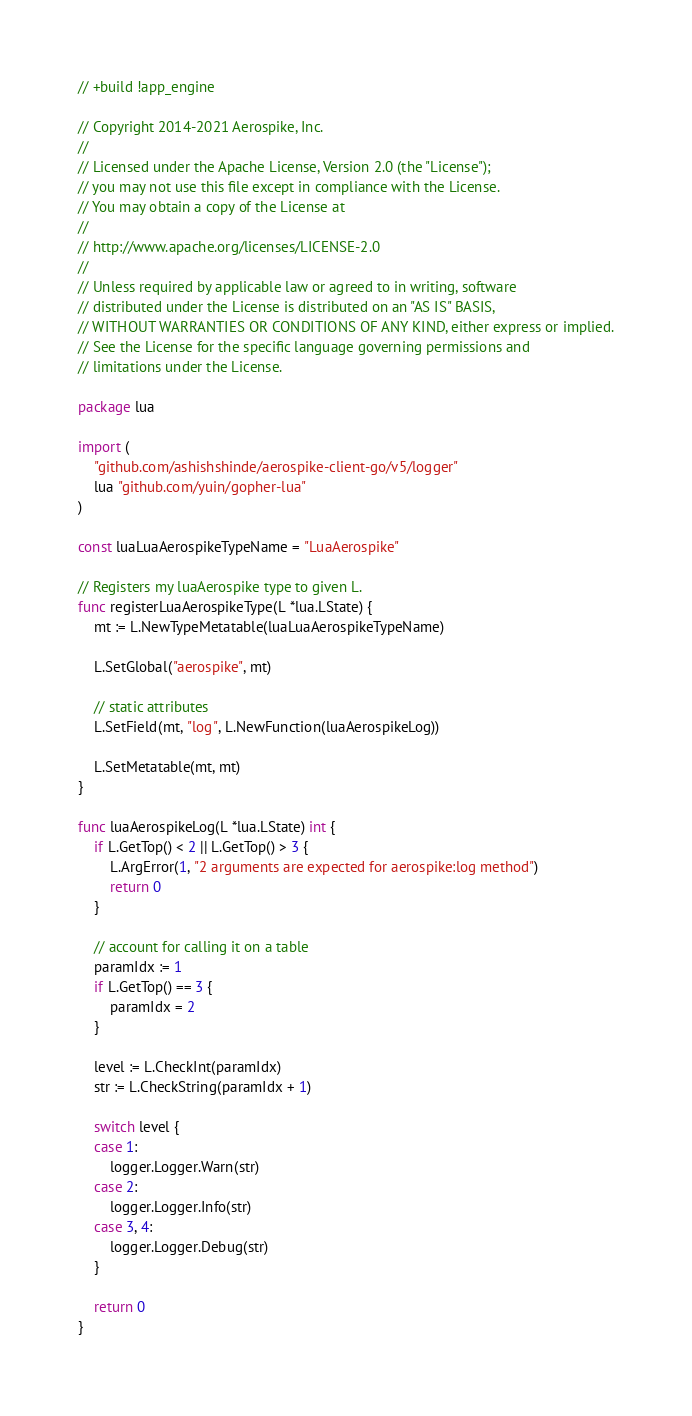Convert code to text. <code><loc_0><loc_0><loc_500><loc_500><_Go_>// +build !app_engine

// Copyright 2014-2021 Aerospike, Inc.
//
// Licensed under the Apache License, Version 2.0 (the "License");
// you may not use this file except in compliance with the License.
// You may obtain a copy of the License at
//
// http://www.apache.org/licenses/LICENSE-2.0
//
// Unless required by applicable law or agreed to in writing, software
// distributed under the License is distributed on an "AS IS" BASIS,
// WITHOUT WARRANTIES OR CONDITIONS OF ANY KIND, either express or implied.
// See the License for the specific language governing permissions and
// limitations under the License.

package lua

import (
	"github.com/ashishshinde/aerospike-client-go/v5/logger"
	lua "github.com/yuin/gopher-lua"
)

const luaLuaAerospikeTypeName = "LuaAerospike"

// Registers my luaAerospike type to given L.
func registerLuaAerospikeType(L *lua.LState) {
	mt := L.NewTypeMetatable(luaLuaAerospikeTypeName)

	L.SetGlobal("aerospike", mt)

	// static attributes
	L.SetField(mt, "log", L.NewFunction(luaAerospikeLog))

	L.SetMetatable(mt, mt)
}

func luaAerospikeLog(L *lua.LState) int {
	if L.GetTop() < 2 || L.GetTop() > 3 {
		L.ArgError(1, "2 arguments are expected for aerospike:log method")
		return 0
	}

	// account for calling it on a table
	paramIdx := 1
	if L.GetTop() == 3 {
		paramIdx = 2
	}

	level := L.CheckInt(paramIdx)
	str := L.CheckString(paramIdx + 1)

	switch level {
	case 1:
		logger.Logger.Warn(str)
	case 2:
		logger.Logger.Info(str)
	case 3, 4:
		logger.Logger.Debug(str)
	}

	return 0
}
</code> 